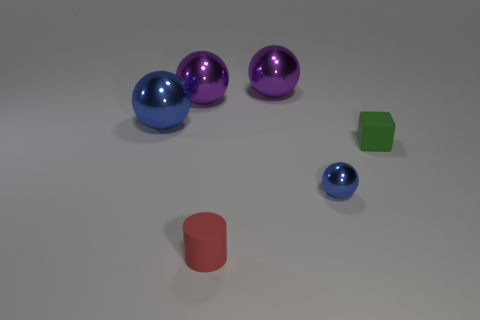Add 1 balls. How many objects exist? 7 Subtract all small balls. How many balls are left? 3 Subtract all cylinders. How many objects are left? 5 Add 6 big blue metallic things. How many big blue metallic things exist? 7 Subtract all purple balls. How many balls are left? 2 Subtract 0 yellow cylinders. How many objects are left? 6 Subtract 1 cylinders. How many cylinders are left? 0 Subtract all brown cylinders. Subtract all cyan cubes. How many cylinders are left? 1 Subtract all blue blocks. How many brown cylinders are left? 0 Subtract all big yellow cylinders. Subtract all green rubber things. How many objects are left? 5 